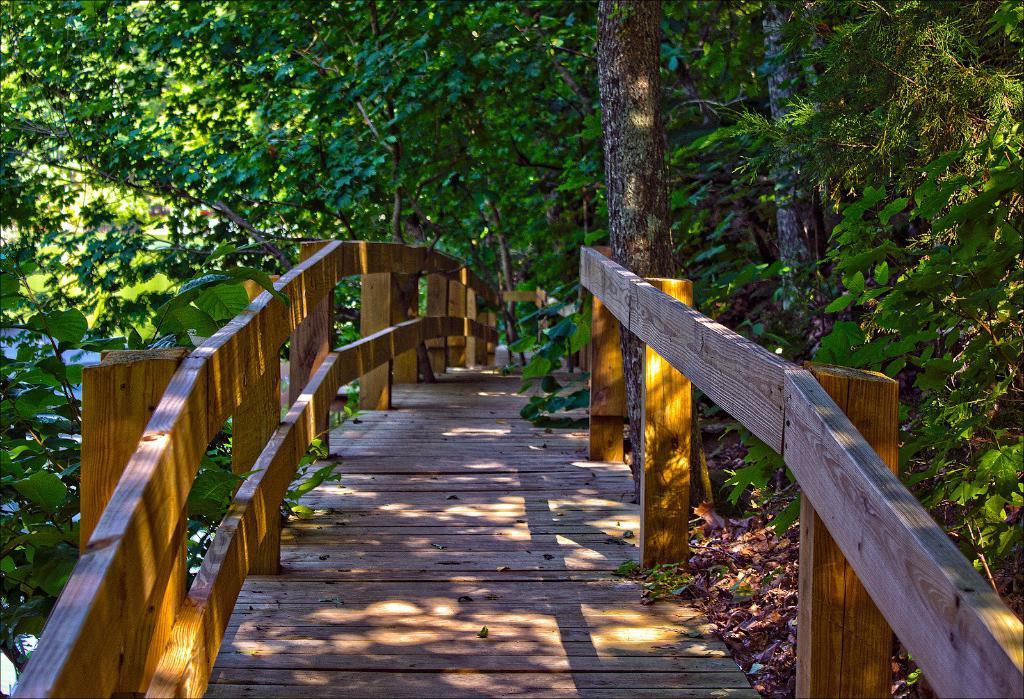What is the main structure in the center of the image? There is a garden bridge in the center of the image. What can be seen in the background of the image? There are trees in the background of the image. What type of plantation can be seen in the image? There is no plantation present in the image; it features a garden bridge and trees in the background. What color is the sheet draped over the garden bridge? There is no sheet present in the image; it only shows the garden bridge and trees in the background. 